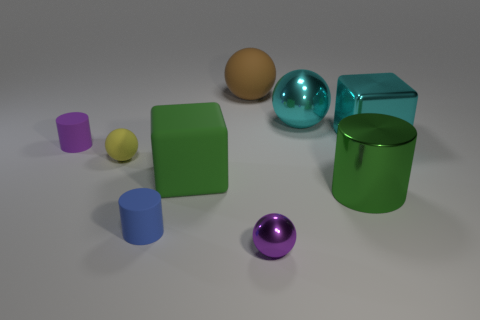Subtract 1 spheres. How many spheres are left? 3 Subtract all brown balls. How many balls are left? 3 Subtract all small purple metallic spheres. How many spheres are left? 3 Add 1 cyan objects. How many objects exist? 10 Subtract all green blocks. Subtract all yellow spheres. How many blocks are left? 1 Subtract all cubes. How many objects are left? 7 Add 5 shiny spheres. How many shiny spheres are left? 7 Add 1 tiny blue cylinders. How many tiny blue cylinders exist? 2 Subtract 0 gray cylinders. How many objects are left? 9 Subtract all big gray matte objects. Subtract all shiny objects. How many objects are left? 5 